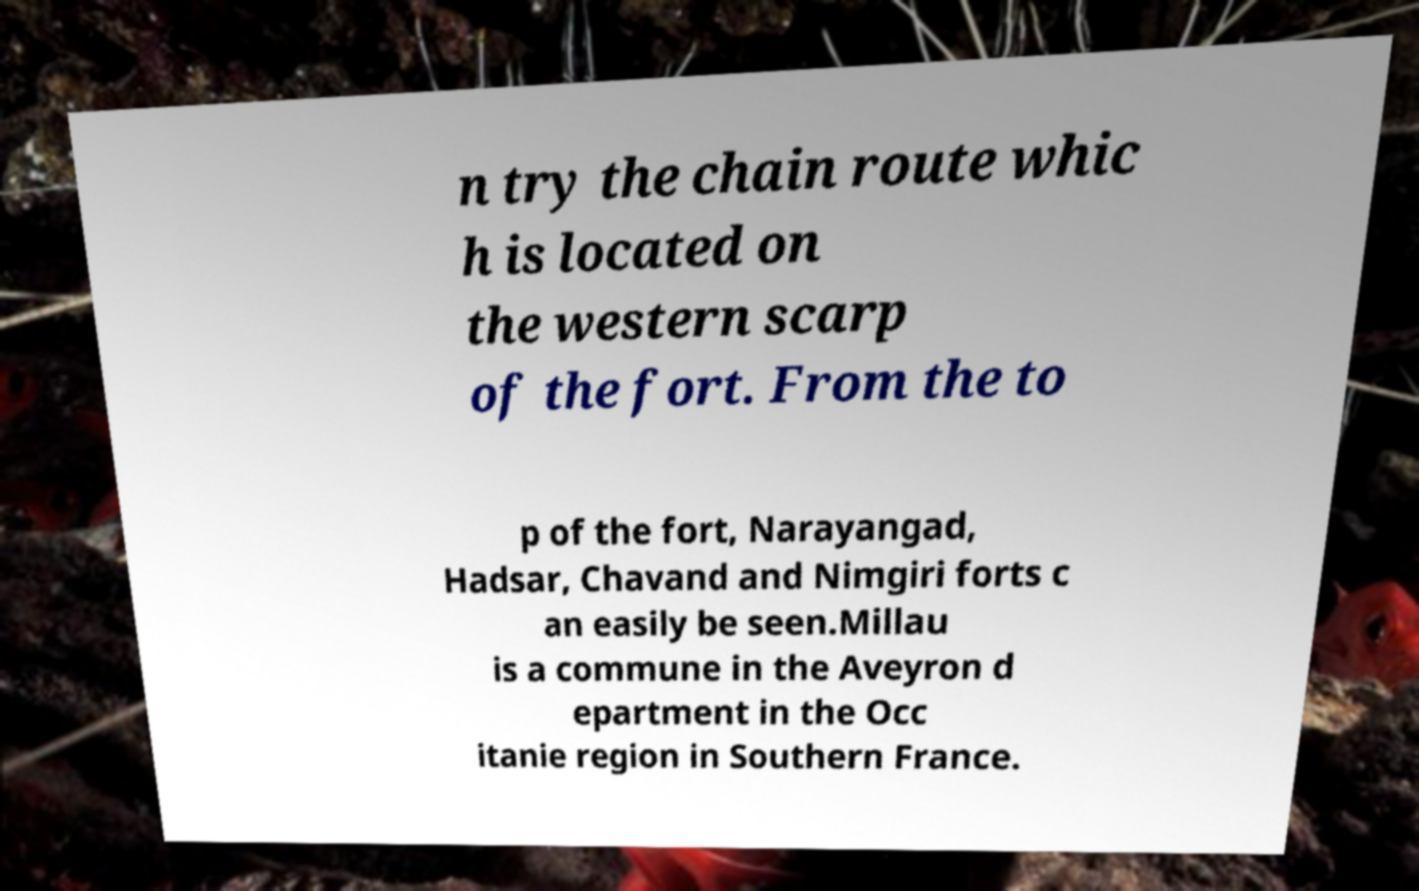I need the written content from this picture converted into text. Can you do that? n try the chain route whic h is located on the western scarp of the fort. From the to p of the fort, Narayangad, Hadsar, Chavand and Nimgiri forts c an easily be seen.Millau is a commune in the Aveyron d epartment in the Occ itanie region in Southern France. 